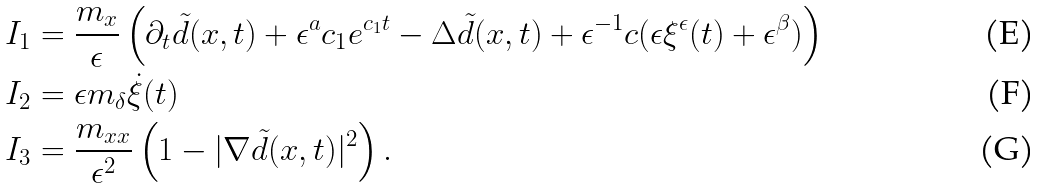<formula> <loc_0><loc_0><loc_500><loc_500>I _ { 1 } & = \frac { m _ { x } } { \epsilon } \left ( \partial _ { t } \tilde { d } ( x , t ) + \epsilon ^ { a } c _ { 1 } e ^ { c _ { 1 } t } - \Delta \tilde { d } ( x , t ) + \epsilon ^ { - 1 } c ( \epsilon \xi ^ { \epsilon } ( t ) + \epsilon ^ { \beta } ) \right ) \\ I _ { 2 } & = \epsilon m _ { \delta } \dot { \xi } ( t ) \\ I _ { 3 } & = \frac { m _ { x x } } { \epsilon ^ { 2 } } \left ( 1 - | \nabla \tilde { d } ( x , t ) | ^ { 2 } \right ) .</formula> 